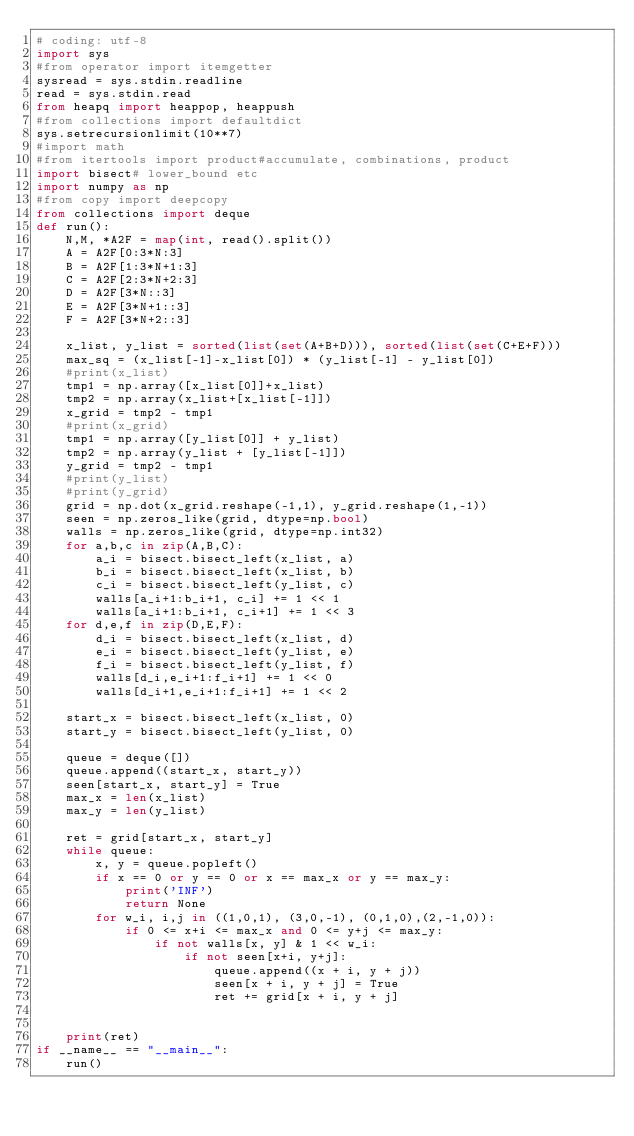<code> <loc_0><loc_0><loc_500><loc_500><_Python_># coding: utf-8
import sys
#from operator import itemgetter
sysread = sys.stdin.readline
read = sys.stdin.read
from heapq import heappop, heappush
#from collections import defaultdict
sys.setrecursionlimit(10**7)
#import math
#from itertools import product#accumulate, combinations, product
import bisect# lower_bound etc
import numpy as np
#from copy import deepcopy
from collections import deque
def run():
    N,M, *A2F = map(int, read().split())
    A = A2F[0:3*N:3]
    B = A2F[1:3*N+1:3]
    C = A2F[2:3*N+2:3]
    D = A2F[3*N::3]
    E = A2F[3*N+1::3]
    F = A2F[3*N+2::3]

    x_list, y_list = sorted(list(set(A+B+D))), sorted(list(set(C+E+F)))
    max_sq = (x_list[-1]-x_list[0]) * (y_list[-1] - y_list[0])
    #print(x_list)
    tmp1 = np.array([x_list[0]]+x_list)
    tmp2 = np.array(x_list+[x_list[-1]])
    x_grid = tmp2 - tmp1
    #print(x_grid)
    tmp1 = np.array([y_list[0]] + y_list)
    tmp2 = np.array(y_list + [y_list[-1]])
    y_grid = tmp2 - tmp1
    #print(y_list)
    #print(y_grid)
    grid = np.dot(x_grid.reshape(-1,1), y_grid.reshape(1,-1))
    seen = np.zeros_like(grid, dtype=np.bool)
    walls = np.zeros_like(grid, dtype=np.int32)
    for a,b,c in zip(A,B,C):
        a_i = bisect.bisect_left(x_list, a)
        b_i = bisect.bisect_left(x_list, b)
        c_i = bisect.bisect_left(y_list, c)
        walls[a_i+1:b_i+1, c_i] += 1 << 1
        walls[a_i+1:b_i+1, c_i+1] += 1 << 3
    for d,e,f in zip(D,E,F):
        d_i = bisect.bisect_left(x_list, d)
        e_i = bisect.bisect_left(y_list, e)
        f_i = bisect.bisect_left(y_list, f)
        walls[d_i,e_i+1:f_i+1] += 1 << 0
        walls[d_i+1,e_i+1:f_i+1] += 1 << 2

    start_x = bisect.bisect_left(x_list, 0)
    start_y = bisect.bisect_left(y_list, 0)

    queue = deque([])
    queue.append((start_x, start_y))
    seen[start_x, start_y] = True
    max_x = len(x_list)
    max_y = len(y_list)

    ret = grid[start_x, start_y]
    while queue:
        x, y = queue.popleft()
        if x == 0 or y == 0 or x == max_x or y == max_y:
            print('INF')
            return None
        for w_i, i,j in ((1,0,1), (3,0,-1), (0,1,0),(2,-1,0)):
            if 0 <= x+i <= max_x and 0 <= y+j <= max_y:
                if not walls[x, y] & 1 << w_i:
                    if not seen[x+i, y+j]:
                        queue.append((x + i, y + j))
                        seen[x + i, y + j] = True
                        ret += grid[x + i, y + j]


    print(ret)
if __name__ == "__main__":
    run()
</code> 